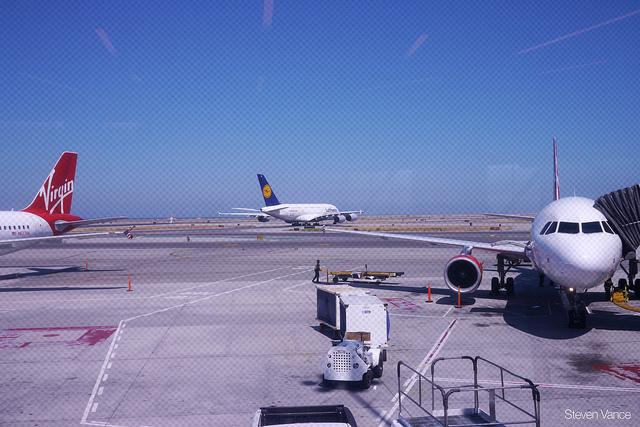What color is the tail fin on the furthest left side of the tarmac?

Choices:
A) red
B) blue
C) yellow
D) green red 